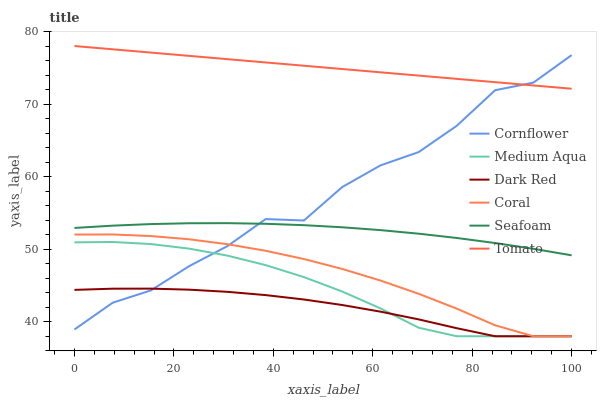Does Dark Red have the minimum area under the curve?
Answer yes or no. Yes. Does Tomato have the maximum area under the curve?
Answer yes or no. Yes. Does Cornflower have the minimum area under the curve?
Answer yes or no. No. Does Cornflower have the maximum area under the curve?
Answer yes or no. No. Is Tomato the smoothest?
Answer yes or no. Yes. Is Cornflower the roughest?
Answer yes or no. Yes. Is Dark Red the smoothest?
Answer yes or no. No. Is Dark Red the roughest?
Answer yes or no. No. Does Dark Red have the lowest value?
Answer yes or no. Yes. Does Cornflower have the lowest value?
Answer yes or no. No. Does Tomato have the highest value?
Answer yes or no. Yes. Does Cornflower have the highest value?
Answer yes or no. No. Is Dark Red less than Tomato?
Answer yes or no. Yes. Is Seafoam greater than Medium Aqua?
Answer yes or no. Yes. Does Cornflower intersect Coral?
Answer yes or no. Yes. Is Cornflower less than Coral?
Answer yes or no. No. Is Cornflower greater than Coral?
Answer yes or no. No. Does Dark Red intersect Tomato?
Answer yes or no. No. 